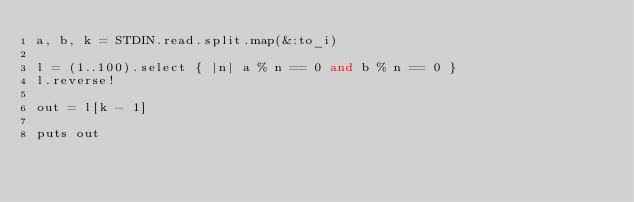Convert code to text. <code><loc_0><loc_0><loc_500><loc_500><_Ruby_>a, b, k = STDIN.read.split.map(&:to_i)

l = (1..100).select { |n| a % n == 0 and b % n == 0 }
l.reverse!

out = l[k - 1]

puts out
</code> 